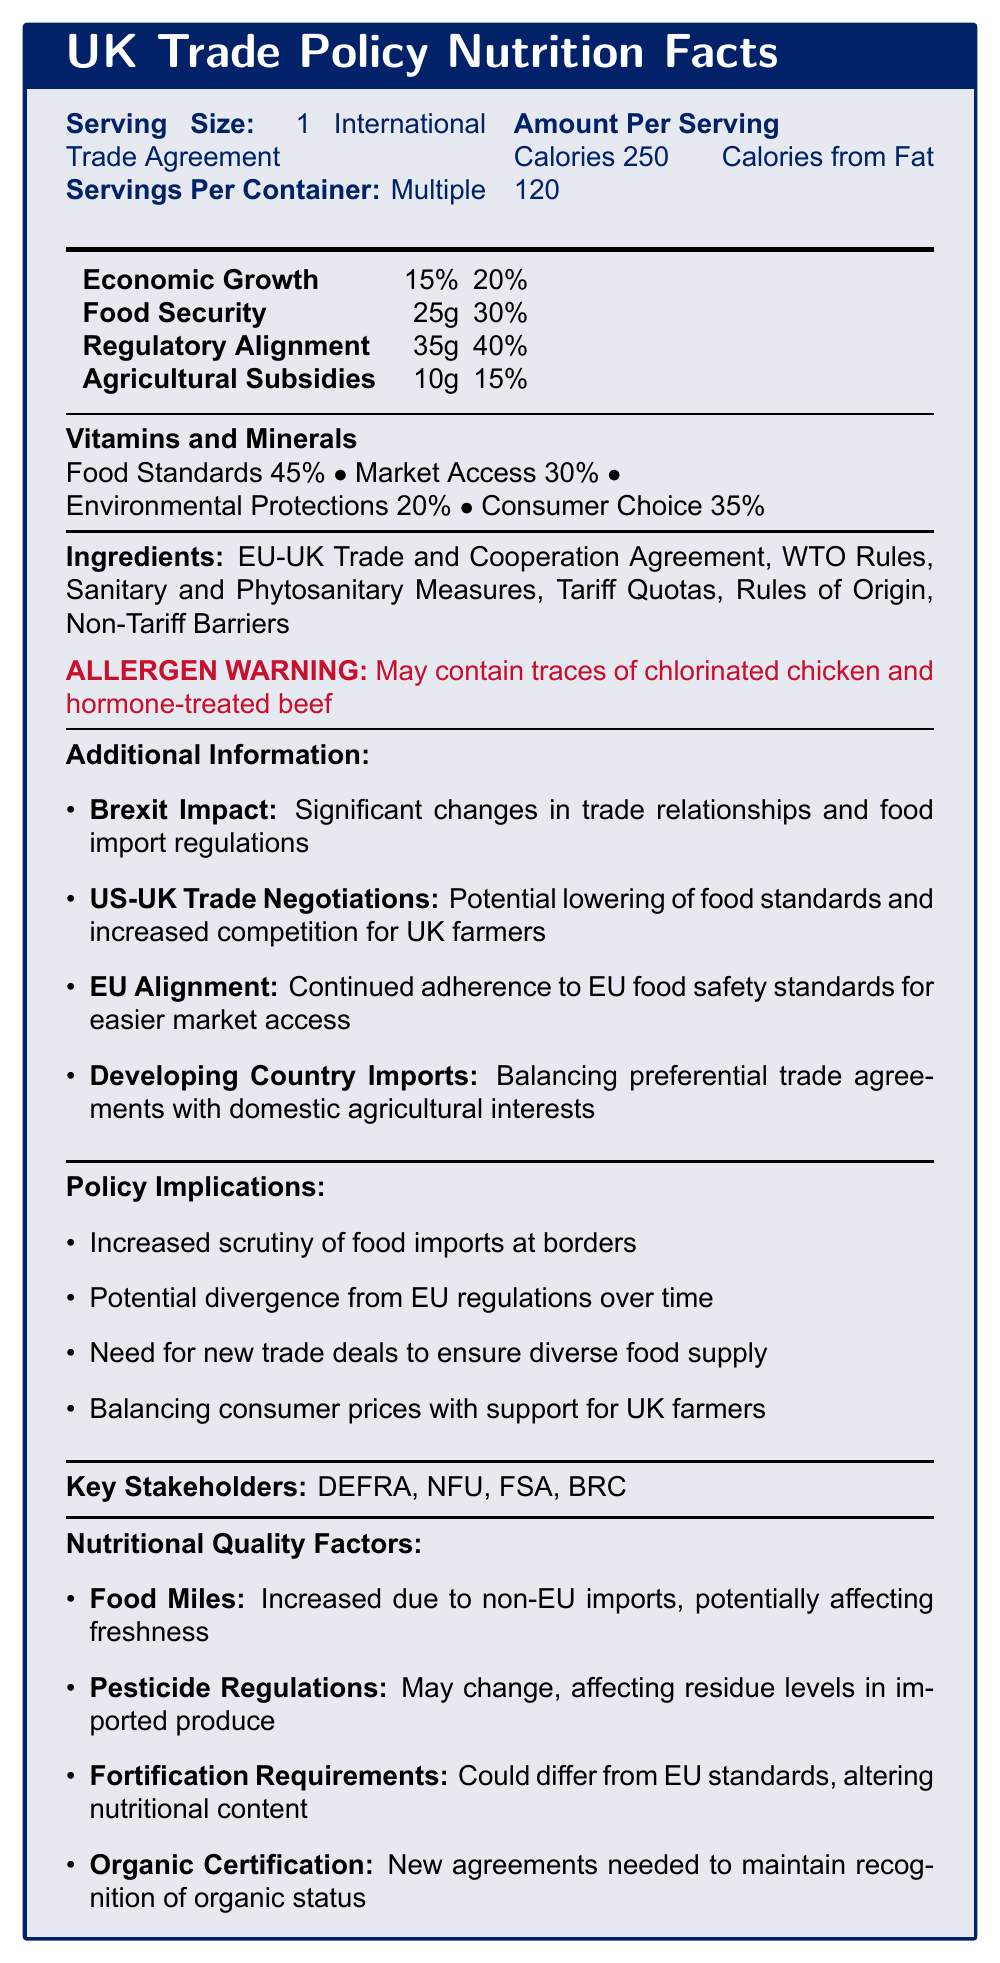what is the serving size mentioned in the document? The document specifies the serving size as "1 International Trade Agreement".
Answer: 1 International Trade Agreement What percentage of Regulatory Alignment is provided per serving? The document indicates that Regulatory Alignment per serving is 35g.
Answer: 35g List two nutrients mentioned in the document along with their daily value percentages. The document lists Economic Growth with a daily value percentage of 20% and Food Security with a daily value percentage of 30%.
Answer: Economic Growth (20%), Food Security (30%) Which ingredient might include traces of chlorinated chicken? The allergen warning in the document mentions "May contain traces of chlorinated chicken and hormone-treated beef", which is an implication of the EU-UK Trade and Cooperation Agreement.
Answer: EU-UK Trade and Cooperation Agreement What agency is listed as a key stakeholder related to food standards? The document lists the Food Standards Agency (FSA) as a key stakeholder.
Answer: Food Standards Agency (FSA) According to the document, which factor affects the freshness of imported food items? The document indicates that "Increased Food Miles" due to non-EU imports potentially affect the freshness of food items.
Answer: Increased Food Miles What potential impact does the US-UK trade negotiation have on UK farmers? The additional information section states that US-UK Trade Negotiations could lead to increased competition for UK farmers.
Answer: Increased competition for UK farmers Which of these is NOT a vitamin and mineral mentioned in the document? A. Environmental Protections B. Regulatory Alignment C. Consumer Choice Regulatory Alignment is not listed as a vitamin and mineral but is mentioned in the daily value nutrients.
Answer: B. Regulatory Alignment Based on the ingredients, which trade measure is likely to involve taxes on imports? A. Sanitary and Phytosanitary Measures B. Tariff Quotas C. Non-Tariff Barriers Tariff Quotas are trade measures involving taxes on imports.
Answer: B. Tariff Quotas True or False: Brexit has no significant impact on trade relationships and food import regulations. The document states that Brexit has significant changes in trade relationships and food import regulations.
Answer: False Summarize the main idea of the document. The document mimics a nutrition facts label to outline the various components and effects of UK trade policy on food imports. It includes information on trade agreements, involved nutrients (economic growth, food security, etc.), and additional factors such as Brexit impact, potential changes in food standards due to US-UK negotiations, and the need to balance domestic agricultural interests with developing country imports. Key stakeholders are also listed.
Answer: Summary: The document provides an assessment of the impact of international trade agreements on food imports and nutritional quality in the UK. It discusses the servings and ingredients, lists specific nutrients and their daily values, identifies key stakeholders, and highlights policy implications and nutritional quality factors. Which department is responsible for environment, food, and rural affairs in the UK? The document lists the Department for Environment, Food and Rural Affairs (DEFRA) as a key stakeholder.
Answer: DEFRA What is the potential effect of changes in pesticide regulations on imported produce? The document mentions that changes in pesticide regulations may affect residue levels in imported produce.
Answer: Affect residue levels in imported produce What is the total amount of Agricultural Subsidies mentioned per serving? The amount per serving for Agricultural Subsidies is listed as 10g in the document.
Answer: 10g What are the potential trade measures mentioned that could impact organic certification? The document lists "Organic Certification" as a nutritional quality factor and highlights the need for new agreements to maintain recognition of organic status.
Answer: New agreements needed to maintain recognition of organic status How many servings are there per container according to the document? The document mentions that there are multiple servings per container.
Answer: Multiple What is the recommended daily value percentage for Economic Growth? The document indicates the daily value percentage for Economic Growth as 20%.
Answer: 20% Describe one of the key implications of new trade deals as mentioned in the policy implications section. The policy implications section highlights that new trade deals are necessary to ensure a diverse food supply.
Answer: Need for new trade deals to ensure diverse food supply What content regarding US-UK trade negotiations is specifically mentioned related to food standards? The document mentions that US-UK Trade Negotiations could potentially lower food standards.
Answer: Potential lowering of food standards How likely is it for regulatory alignment to continue with EU food safety standards? The document suggests that there will be continued adherence to EU food safety standards for easier market access.
Answer: Continued adherence What is the Environmental Protections percentage? The percentage for Environmental Protections listed in the Vitamins and Minerals section is 20%.
Answer: 20% Which type of barrier is part of the ingredients listed in the document? A. Tariff Barriers B. Non-Tariff Barriers C. Price Barriers Non-Tariff Barriers are listed as one of the ingredients.
Answer: B. Non-Tariff Barriers Explain the main focus of the 'Brexit Impact' additional information section. The 'Brexit Impact' section is focused on the significant changes in trade relationships and food import regulations resulting from Brexit.
Answer: Significant changes in trade relationships and food import regulations Cannot be determined: Which specific food items are most affected by UK trade policy changes? The document does not provide specific food items that are affected by UK trade policy changes.
Answer: Cannot be determined 